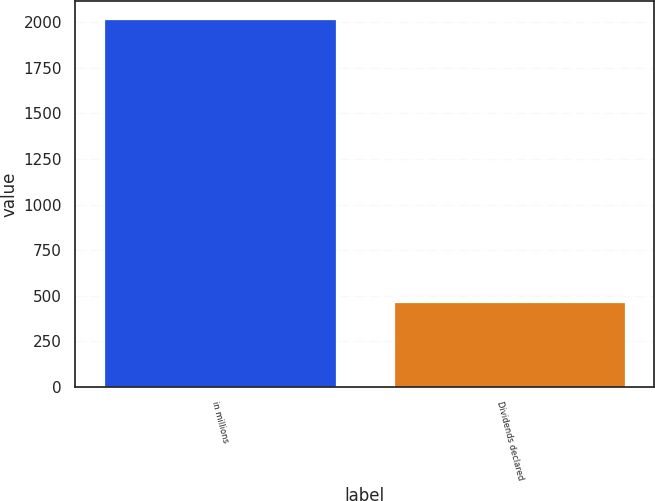Convert chart to OTSL. <chart><loc_0><loc_0><loc_500><loc_500><bar_chart><fcel>in millions<fcel>Dividends declared<nl><fcel>2016<fcel>468<nl></chart> 